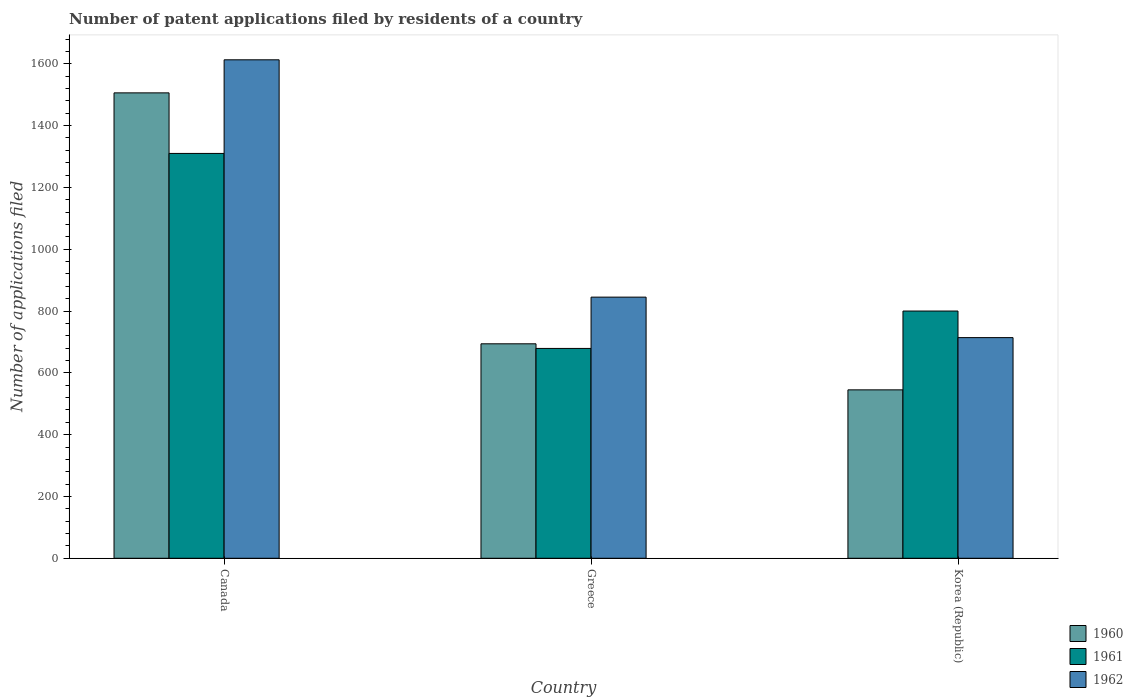How many different coloured bars are there?
Your answer should be very brief. 3. How many groups of bars are there?
Your answer should be compact. 3. Are the number of bars per tick equal to the number of legend labels?
Offer a very short reply. Yes. Are the number of bars on each tick of the X-axis equal?
Make the answer very short. Yes. How many bars are there on the 1st tick from the left?
Offer a terse response. 3. In how many cases, is the number of bars for a given country not equal to the number of legend labels?
Offer a terse response. 0. What is the number of applications filed in 1960 in Greece?
Provide a short and direct response. 694. Across all countries, what is the maximum number of applications filed in 1961?
Ensure brevity in your answer.  1310. Across all countries, what is the minimum number of applications filed in 1962?
Offer a very short reply. 714. What is the total number of applications filed in 1960 in the graph?
Offer a very short reply. 2745. What is the difference between the number of applications filed in 1961 in Canada and that in Greece?
Provide a succinct answer. 631. What is the difference between the number of applications filed in 1962 in Korea (Republic) and the number of applications filed in 1961 in Canada?
Your answer should be very brief. -596. What is the average number of applications filed in 1961 per country?
Ensure brevity in your answer.  929.67. What is the difference between the number of applications filed of/in 1962 and number of applications filed of/in 1960 in Korea (Republic)?
Offer a very short reply. 169. In how many countries, is the number of applications filed in 1962 greater than 120?
Provide a short and direct response. 3. What is the ratio of the number of applications filed in 1962 in Canada to that in Korea (Republic)?
Make the answer very short. 2.26. Is the difference between the number of applications filed in 1962 in Greece and Korea (Republic) greater than the difference between the number of applications filed in 1960 in Greece and Korea (Republic)?
Your answer should be compact. No. What is the difference between the highest and the second highest number of applications filed in 1962?
Offer a terse response. -131. What is the difference between the highest and the lowest number of applications filed in 1960?
Provide a short and direct response. 961. Is the sum of the number of applications filed in 1960 in Greece and Korea (Republic) greater than the maximum number of applications filed in 1962 across all countries?
Offer a terse response. No. What does the 1st bar from the left in Korea (Republic) represents?
Provide a succinct answer. 1960. What does the 2nd bar from the right in Korea (Republic) represents?
Offer a very short reply. 1961. How are the legend labels stacked?
Your answer should be compact. Vertical. What is the title of the graph?
Provide a succinct answer. Number of patent applications filed by residents of a country. What is the label or title of the Y-axis?
Provide a short and direct response. Number of applications filed. What is the Number of applications filed of 1960 in Canada?
Offer a terse response. 1506. What is the Number of applications filed of 1961 in Canada?
Provide a succinct answer. 1310. What is the Number of applications filed of 1962 in Canada?
Your answer should be compact. 1613. What is the Number of applications filed of 1960 in Greece?
Your response must be concise. 694. What is the Number of applications filed of 1961 in Greece?
Provide a short and direct response. 679. What is the Number of applications filed of 1962 in Greece?
Provide a succinct answer. 845. What is the Number of applications filed of 1960 in Korea (Republic)?
Provide a succinct answer. 545. What is the Number of applications filed of 1961 in Korea (Republic)?
Offer a terse response. 800. What is the Number of applications filed in 1962 in Korea (Republic)?
Your answer should be compact. 714. Across all countries, what is the maximum Number of applications filed of 1960?
Provide a succinct answer. 1506. Across all countries, what is the maximum Number of applications filed of 1961?
Ensure brevity in your answer.  1310. Across all countries, what is the maximum Number of applications filed in 1962?
Give a very brief answer. 1613. Across all countries, what is the minimum Number of applications filed of 1960?
Give a very brief answer. 545. Across all countries, what is the minimum Number of applications filed of 1961?
Offer a terse response. 679. Across all countries, what is the minimum Number of applications filed in 1962?
Make the answer very short. 714. What is the total Number of applications filed of 1960 in the graph?
Provide a short and direct response. 2745. What is the total Number of applications filed of 1961 in the graph?
Offer a very short reply. 2789. What is the total Number of applications filed of 1962 in the graph?
Your response must be concise. 3172. What is the difference between the Number of applications filed in 1960 in Canada and that in Greece?
Ensure brevity in your answer.  812. What is the difference between the Number of applications filed of 1961 in Canada and that in Greece?
Your answer should be compact. 631. What is the difference between the Number of applications filed in 1962 in Canada and that in Greece?
Give a very brief answer. 768. What is the difference between the Number of applications filed in 1960 in Canada and that in Korea (Republic)?
Ensure brevity in your answer.  961. What is the difference between the Number of applications filed in 1961 in Canada and that in Korea (Republic)?
Provide a short and direct response. 510. What is the difference between the Number of applications filed of 1962 in Canada and that in Korea (Republic)?
Offer a very short reply. 899. What is the difference between the Number of applications filed of 1960 in Greece and that in Korea (Republic)?
Provide a short and direct response. 149. What is the difference between the Number of applications filed of 1961 in Greece and that in Korea (Republic)?
Keep it short and to the point. -121. What is the difference between the Number of applications filed of 1962 in Greece and that in Korea (Republic)?
Ensure brevity in your answer.  131. What is the difference between the Number of applications filed in 1960 in Canada and the Number of applications filed in 1961 in Greece?
Keep it short and to the point. 827. What is the difference between the Number of applications filed of 1960 in Canada and the Number of applications filed of 1962 in Greece?
Ensure brevity in your answer.  661. What is the difference between the Number of applications filed in 1961 in Canada and the Number of applications filed in 1962 in Greece?
Make the answer very short. 465. What is the difference between the Number of applications filed in 1960 in Canada and the Number of applications filed in 1961 in Korea (Republic)?
Offer a terse response. 706. What is the difference between the Number of applications filed of 1960 in Canada and the Number of applications filed of 1962 in Korea (Republic)?
Make the answer very short. 792. What is the difference between the Number of applications filed in 1961 in Canada and the Number of applications filed in 1962 in Korea (Republic)?
Provide a succinct answer. 596. What is the difference between the Number of applications filed of 1960 in Greece and the Number of applications filed of 1961 in Korea (Republic)?
Ensure brevity in your answer.  -106. What is the difference between the Number of applications filed of 1960 in Greece and the Number of applications filed of 1962 in Korea (Republic)?
Provide a succinct answer. -20. What is the difference between the Number of applications filed in 1961 in Greece and the Number of applications filed in 1962 in Korea (Republic)?
Ensure brevity in your answer.  -35. What is the average Number of applications filed of 1960 per country?
Your answer should be very brief. 915. What is the average Number of applications filed of 1961 per country?
Your response must be concise. 929.67. What is the average Number of applications filed in 1962 per country?
Make the answer very short. 1057.33. What is the difference between the Number of applications filed in 1960 and Number of applications filed in 1961 in Canada?
Offer a terse response. 196. What is the difference between the Number of applications filed of 1960 and Number of applications filed of 1962 in Canada?
Your answer should be compact. -107. What is the difference between the Number of applications filed of 1961 and Number of applications filed of 1962 in Canada?
Provide a succinct answer. -303. What is the difference between the Number of applications filed of 1960 and Number of applications filed of 1961 in Greece?
Give a very brief answer. 15. What is the difference between the Number of applications filed of 1960 and Number of applications filed of 1962 in Greece?
Your answer should be compact. -151. What is the difference between the Number of applications filed in 1961 and Number of applications filed in 1962 in Greece?
Your answer should be very brief. -166. What is the difference between the Number of applications filed of 1960 and Number of applications filed of 1961 in Korea (Republic)?
Provide a succinct answer. -255. What is the difference between the Number of applications filed of 1960 and Number of applications filed of 1962 in Korea (Republic)?
Keep it short and to the point. -169. What is the difference between the Number of applications filed in 1961 and Number of applications filed in 1962 in Korea (Republic)?
Your answer should be compact. 86. What is the ratio of the Number of applications filed of 1960 in Canada to that in Greece?
Keep it short and to the point. 2.17. What is the ratio of the Number of applications filed of 1961 in Canada to that in Greece?
Your response must be concise. 1.93. What is the ratio of the Number of applications filed of 1962 in Canada to that in Greece?
Offer a terse response. 1.91. What is the ratio of the Number of applications filed of 1960 in Canada to that in Korea (Republic)?
Offer a very short reply. 2.76. What is the ratio of the Number of applications filed in 1961 in Canada to that in Korea (Republic)?
Provide a short and direct response. 1.64. What is the ratio of the Number of applications filed of 1962 in Canada to that in Korea (Republic)?
Your answer should be compact. 2.26. What is the ratio of the Number of applications filed of 1960 in Greece to that in Korea (Republic)?
Offer a very short reply. 1.27. What is the ratio of the Number of applications filed of 1961 in Greece to that in Korea (Republic)?
Keep it short and to the point. 0.85. What is the ratio of the Number of applications filed of 1962 in Greece to that in Korea (Republic)?
Offer a very short reply. 1.18. What is the difference between the highest and the second highest Number of applications filed of 1960?
Your answer should be very brief. 812. What is the difference between the highest and the second highest Number of applications filed in 1961?
Give a very brief answer. 510. What is the difference between the highest and the second highest Number of applications filed in 1962?
Provide a short and direct response. 768. What is the difference between the highest and the lowest Number of applications filed in 1960?
Keep it short and to the point. 961. What is the difference between the highest and the lowest Number of applications filed of 1961?
Your answer should be compact. 631. What is the difference between the highest and the lowest Number of applications filed of 1962?
Offer a terse response. 899. 